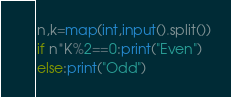Convert code to text. <code><loc_0><loc_0><loc_500><loc_500><_Python_>n,k=map(int,input().split())
if n*K%2==0:print("Even")
else:print("Odd")</code> 